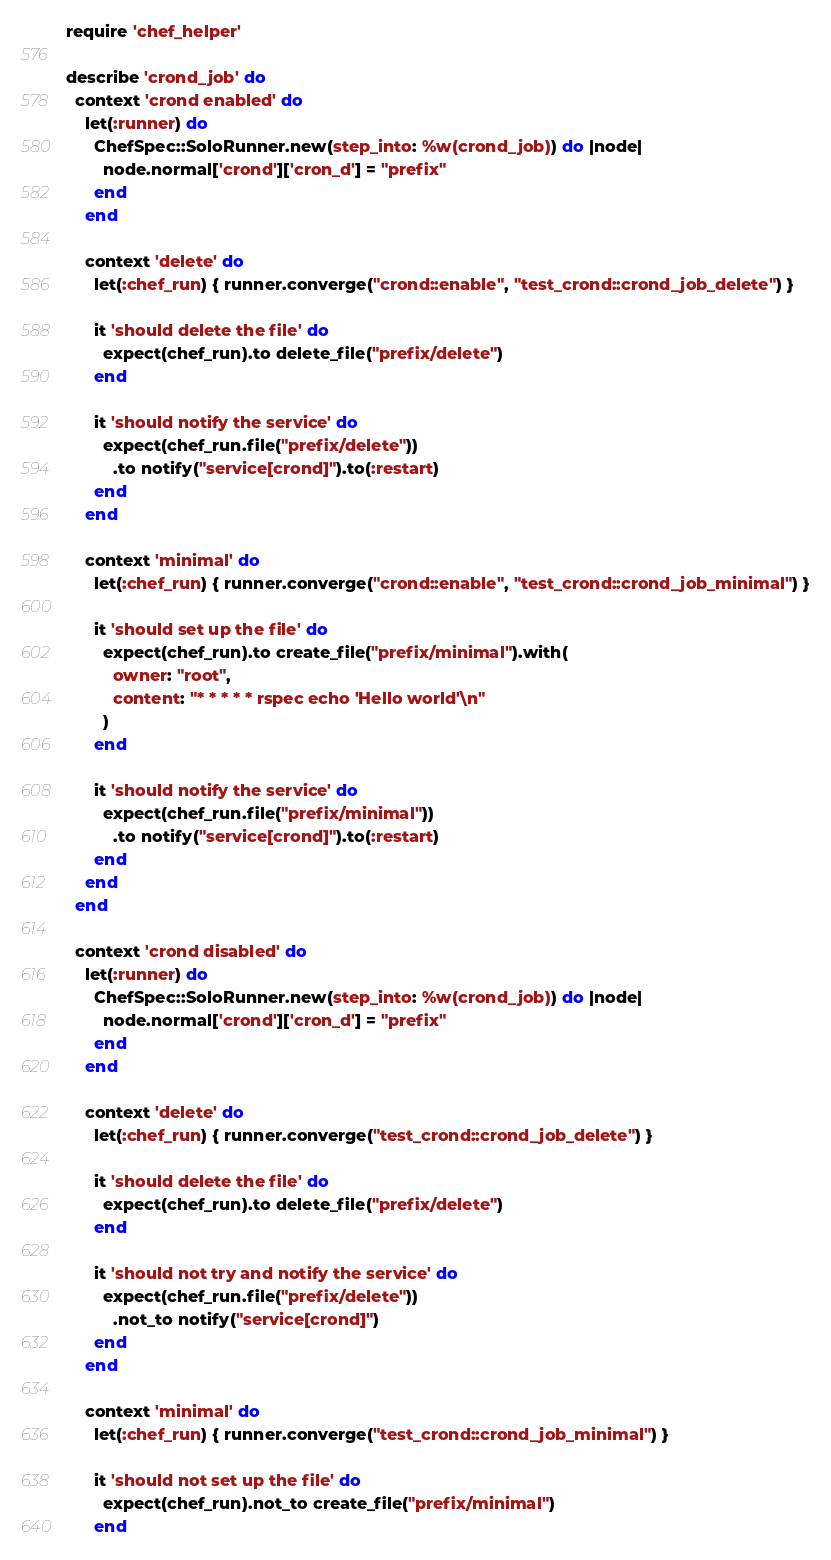Convert code to text. <code><loc_0><loc_0><loc_500><loc_500><_Ruby_>require 'chef_helper'

describe 'crond_job' do
  context 'crond enabled' do
    let(:runner) do
      ChefSpec::SoloRunner.new(step_into: %w(crond_job)) do |node|
        node.normal['crond']['cron_d'] = "prefix"
      end
    end

    context 'delete' do
      let(:chef_run) { runner.converge("crond::enable", "test_crond::crond_job_delete") }

      it 'should delete the file' do
        expect(chef_run).to delete_file("prefix/delete")
      end

      it 'should notify the service' do
        expect(chef_run.file("prefix/delete"))
          .to notify("service[crond]").to(:restart)
      end
    end

    context 'minimal' do
      let(:chef_run) { runner.converge("crond::enable", "test_crond::crond_job_minimal") }

      it 'should set up the file' do
        expect(chef_run).to create_file("prefix/minimal").with(
          owner: "root",
          content: "* * * * * rspec echo 'Hello world'\n"
        )
      end

      it 'should notify the service' do
        expect(chef_run.file("prefix/minimal"))
          .to notify("service[crond]").to(:restart)
      end
    end
  end

  context 'crond disabled' do
    let(:runner) do
      ChefSpec::SoloRunner.new(step_into: %w(crond_job)) do |node|
        node.normal['crond']['cron_d'] = "prefix"
      end
    end

    context 'delete' do
      let(:chef_run) { runner.converge("test_crond::crond_job_delete") }

      it 'should delete the file' do
        expect(chef_run).to delete_file("prefix/delete")
      end

      it 'should not try and notify the service' do
        expect(chef_run.file("prefix/delete"))
          .not_to notify("service[crond]")
      end
    end

    context 'minimal' do
      let(:chef_run) { runner.converge("test_crond::crond_job_minimal") }

      it 'should not set up the file' do
        expect(chef_run).not_to create_file("prefix/minimal")
      end</code> 